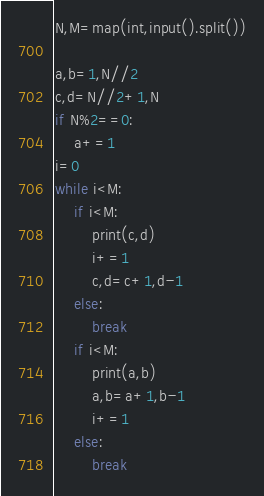<code> <loc_0><loc_0><loc_500><loc_500><_Python_>N,M=map(int,input().split())

a,b=1,N//2
c,d=N//2+1,N
if N%2==0:
    a+=1
i=0
while i<M:
    if i<M:
        print(c,d)
        i+=1        
        c,d=c+1,d-1
    else:
        break
    if i<M:
        print(a,b)
        a,b=a+1,b-1
        i+=1
    else:
        break
</code> 